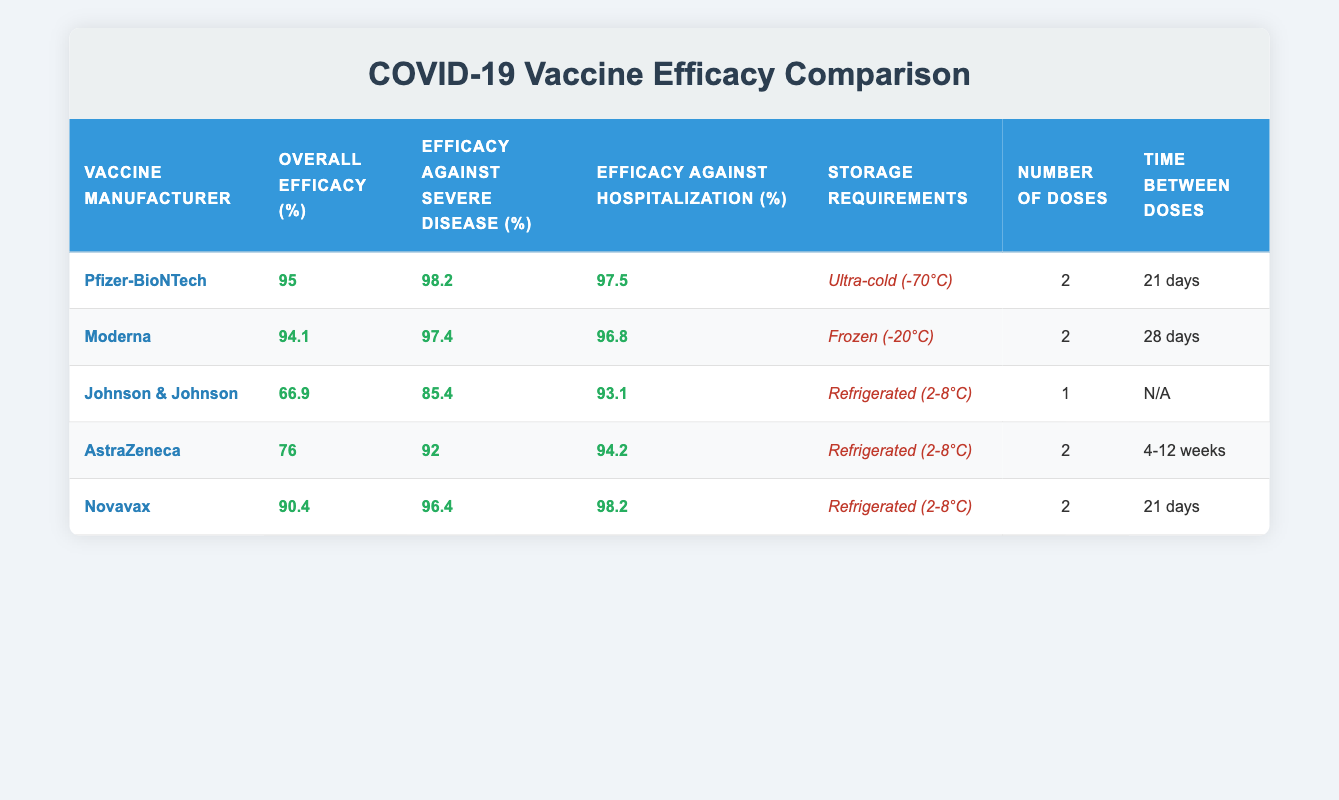What is the overall efficacy percentage of the Pfizer-BioNTech vaccine? The overall efficacy percentage of the Pfizer-BioNTech vaccine is listed directly in the table under the "Overall Efficacy (%)" column. Referring to the table, it indicates 95%.
Answer: 95% Which vaccine has the highest efficacy against hospitalization? To find this, we need to compare the "Efficacy Against Hospitalization (%)" values of all vaccines in the table. By examining the values, Novavax has 98.2%, which is the highest among all listed.
Answer: 98.2% Does the Johnson & Johnson vaccine require more than one dose? In the table, the "Number of Doses" for the Johnson & Johnson vaccine is 1, indicating it does not require more than one dose. Therefore, the answer is no.
Answer: No What is the storage requirement for the Moderna vaccine? The storage requirement for the Moderna vaccine is directly mentioned in the "Storage Requirements" column of the table, where it is indicated as "Frozen (-20°C)".
Answer: Frozen (-20°C) Calculate the average overall efficacy of the vaccines listed. To find the average, we sum the overall efficacy percentages: 95 + 94.1 + 66.9 + 76 + 90.4 = 422.4. There are 5 vaccines, so we divide this sum by 5: 422.4/5 = 84.48.
Answer: 84.48 Which vaccine has the lowest efficacy against severe disease? By checking the "Efficacy Against Severe Disease (%)" column, we find that the Johnson & Johnson vaccine has 85.4%, which is the lowest figure among all the vaccines listed.
Answer: 85.4% Is the AstraZeneca vaccine effective against severe disease by at least 90%? In the table, we find that the efficacy against severe disease for AstraZeneca is 92%, which is indeed 90% or higher. Thus, the answer is yes.
Answer: Yes What is the time between doses for the Novavax vaccine? Referring to the table, the "Time Between Doses" for the Novavax vaccine is listed as "21 days". This value answers the question directly and simply.
Answer: 21 days If a person receives the Moderna vaccine, how many total doses do they need? The table indicates that the Moderna vaccine requires 2 doses as specified under the "Number of Doses" column.
Answer: 2 